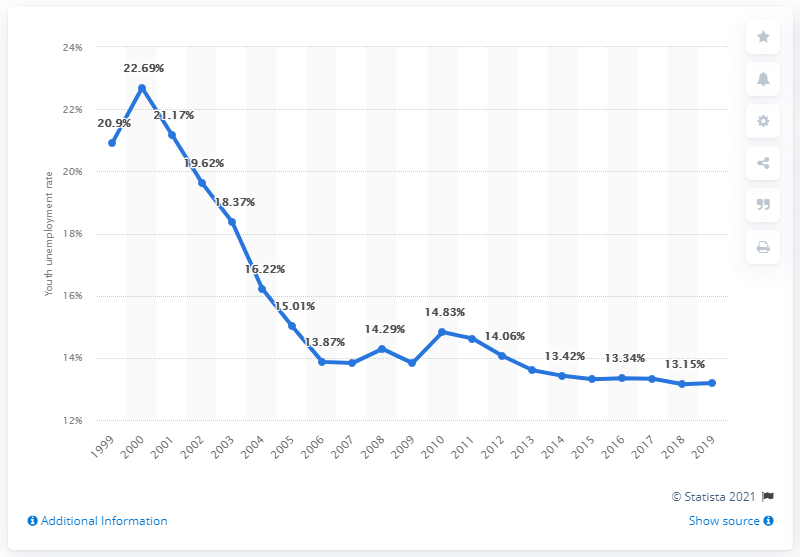List a handful of essential elements in this visual. According to the data, the youth unemployment rate in Azerbaijan was 13.19% in 2019. 